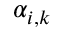<formula> <loc_0><loc_0><loc_500><loc_500>\alpha _ { i , k }</formula> 